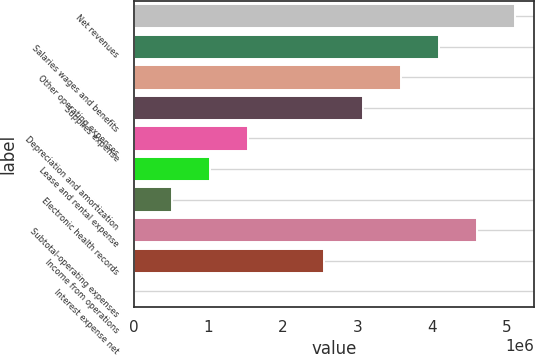Convert chart to OTSL. <chart><loc_0><loc_0><loc_500><loc_500><bar_chart><fcel>Net revenues<fcel>Salaries wages and benefits<fcel>Other operating expenses<fcel>Supplies expense<fcel>Depreciation and amortization<fcel>Lease and rental expense<fcel>Electronic health records<fcel>Subtotal-operating expenses<fcel>Income from operations<fcel>Interest expense net<nl><fcel>5.11295e+06<fcel>4.09102e+06<fcel>3.58005e+06<fcel>3.06908e+06<fcel>1.53618e+06<fcel>1.02521e+06<fcel>514244<fcel>4.60198e+06<fcel>2.55811e+06<fcel>3277<nl></chart> 